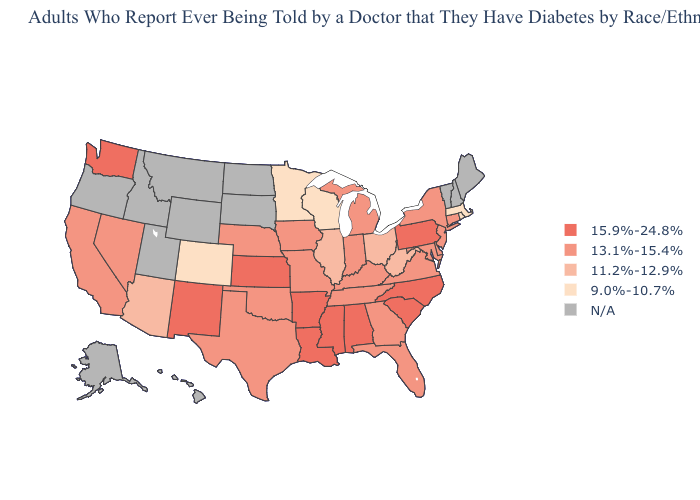Which states hav the highest value in the Northeast?
Be succinct. Pennsylvania. Does the first symbol in the legend represent the smallest category?
Concise answer only. No. How many symbols are there in the legend?
Quick response, please. 5. Name the states that have a value in the range 11.2%-12.9%?
Answer briefly. Arizona, Illinois, Ohio, West Virginia. What is the highest value in states that border Nevada?
Answer briefly. 13.1%-15.4%. What is the value of New Hampshire?
Write a very short answer. N/A. What is the value of Kentucky?
Quick response, please. 13.1%-15.4%. What is the value of Indiana?
Concise answer only. 13.1%-15.4%. What is the lowest value in states that border Florida?
Quick response, please. 13.1%-15.4%. Which states have the lowest value in the USA?
Short answer required. Colorado, Massachusetts, Minnesota, Rhode Island, Wisconsin. Does Arizona have the lowest value in the USA?
Be succinct. No. Name the states that have a value in the range N/A?
Keep it brief. Alaska, Hawaii, Idaho, Maine, Montana, New Hampshire, North Dakota, Oregon, South Dakota, Utah, Vermont, Wyoming. Name the states that have a value in the range 9.0%-10.7%?
Short answer required. Colorado, Massachusetts, Minnesota, Rhode Island, Wisconsin. What is the highest value in the Northeast ?
Write a very short answer. 15.9%-24.8%. 